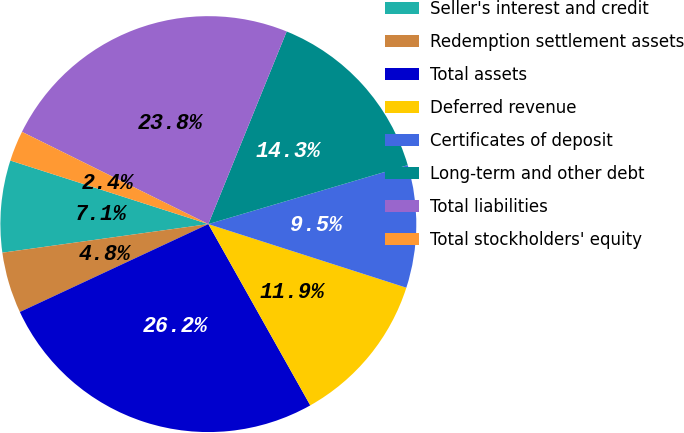Convert chart. <chart><loc_0><loc_0><loc_500><loc_500><pie_chart><fcel>Seller's interest and credit<fcel>Redemption settlement assets<fcel>Total assets<fcel>Deferred revenue<fcel>Certificates of deposit<fcel>Long-term and other debt<fcel>Total liabilities<fcel>Total stockholders' equity<nl><fcel>7.14%<fcel>4.75%<fcel>26.21%<fcel>11.9%<fcel>9.52%<fcel>14.28%<fcel>23.83%<fcel>2.37%<nl></chart> 